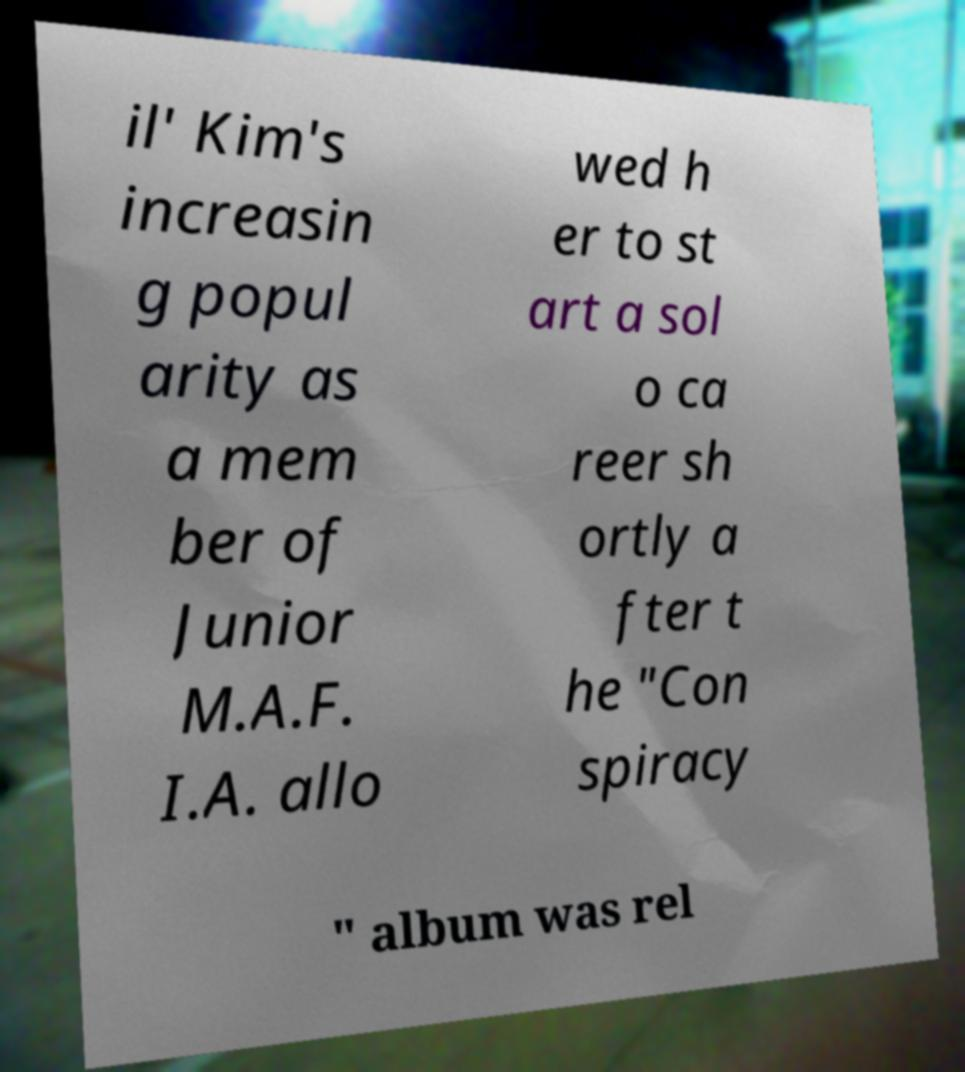Can you read and provide the text displayed in the image?This photo seems to have some interesting text. Can you extract and type it out for me? il' Kim's increasin g popul arity as a mem ber of Junior M.A.F. I.A. allo wed h er to st art a sol o ca reer sh ortly a fter t he "Con spiracy " album was rel 